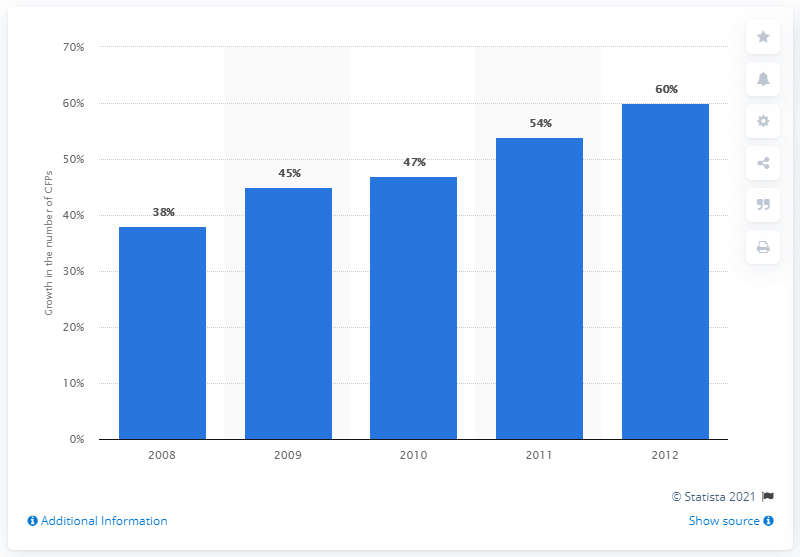Point out several critical features in this image. In 2008, the number of crowdfunding platforms worldwide increased by 38%. 